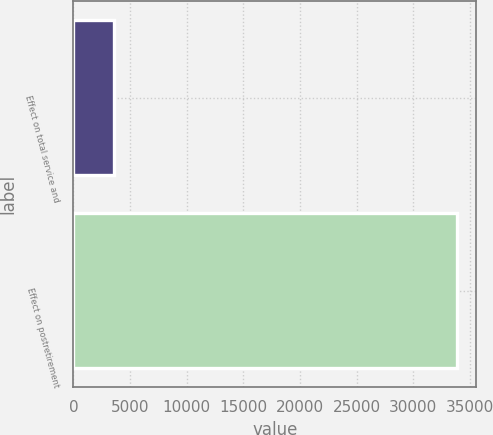<chart> <loc_0><loc_0><loc_500><loc_500><bar_chart><fcel>Effect on total service and<fcel>Effect on postretirement<nl><fcel>3584<fcel>33863<nl></chart> 